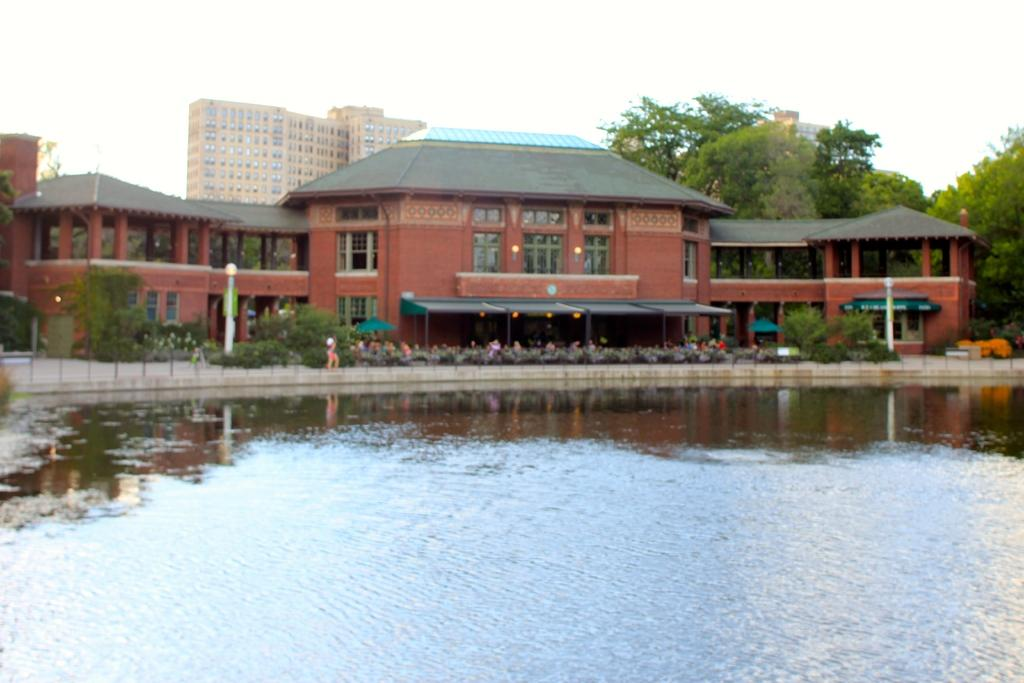What type of structures are located in the center of the image? There are houses and buildings in the center of the image. What other elements can be seen in the center of the image? There are trees and plants in the center of the image. What type of surface is present in the image? There is a pavement in the image. What are the tall, thin objects in the image? There are poles in the image. What body of water is visible at the bottom of the image? There is a pond at the bottom of the image. What is visible at the top of the image? The sky is visible at the top of the image. Can you see a monkey climbing one of the poles in the image? There is no monkey present in the image; it only features houses, buildings, trees, plants, pavement, poles, a pond, and the sky. What type of ear is visible on the pond in the image? There is no ear present in the image, as it is a pond and not a living being. 